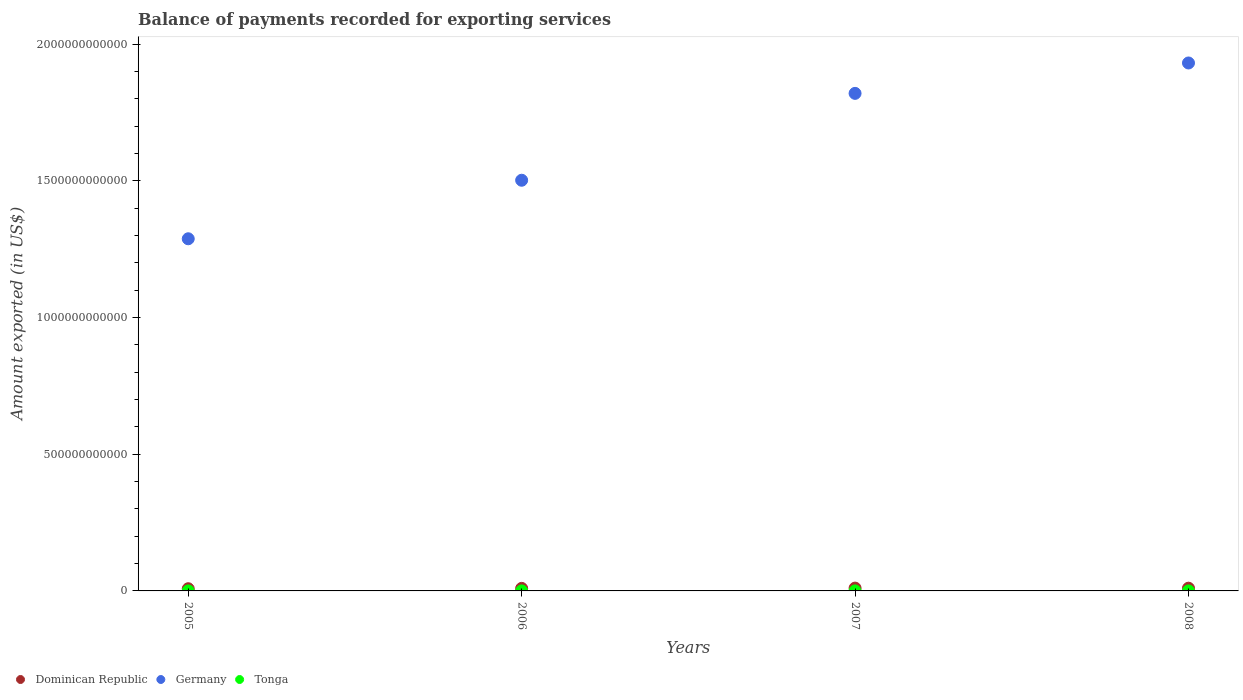How many different coloured dotlines are there?
Your response must be concise. 3. Is the number of dotlines equal to the number of legend labels?
Ensure brevity in your answer.  Yes. What is the amount exported in Tonga in 2007?
Your answer should be compact. 5.55e+07. Across all years, what is the maximum amount exported in Tonga?
Make the answer very short. 6.01e+07. Across all years, what is the minimum amount exported in Germany?
Your response must be concise. 1.29e+12. In which year was the amount exported in Germany maximum?
Make the answer very short. 2008. What is the total amount exported in Dominican Republic in the graph?
Provide a succinct answer. 3.76e+1. What is the difference between the amount exported in Germany in 2005 and that in 2006?
Keep it short and to the point. -2.14e+11. What is the difference between the amount exported in Tonga in 2007 and the amount exported in Dominican Republic in 2008?
Your answer should be compact. -9.94e+09. What is the average amount exported in Germany per year?
Offer a terse response. 1.64e+12. In the year 2007, what is the difference between the amount exported in Germany and amount exported in Dominican Republic?
Your answer should be compact. 1.81e+12. In how many years, is the amount exported in Tonga greater than 900000000000 US$?
Keep it short and to the point. 0. What is the ratio of the amount exported in Germany in 2005 to that in 2007?
Provide a succinct answer. 0.71. Is the amount exported in Tonga in 2005 less than that in 2007?
Ensure brevity in your answer.  No. Is the difference between the amount exported in Germany in 2005 and 2007 greater than the difference between the amount exported in Dominican Republic in 2005 and 2007?
Offer a terse response. No. What is the difference between the highest and the second highest amount exported in Dominican Republic?
Your response must be concise. 3.16e+08. What is the difference between the highest and the lowest amount exported in Germany?
Your answer should be compact. 6.43e+11. In how many years, is the amount exported in Germany greater than the average amount exported in Germany taken over all years?
Your answer should be compact. 2. Is it the case that in every year, the sum of the amount exported in Tonga and amount exported in Dominican Republic  is greater than the amount exported in Germany?
Give a very brief answer. No. Is the amount exported in Dominican Republic strictly greater than the amount exported in Tonga over the years?
Keep it short and to the point. Yes. How many years are there in the graph?
Provide a succinct answer. 4. What is the difference between two consecutive major ticks on the Y-axis?
Keep it short and to the point. 5.00e+11. Are the values on the major ticks of Y-axis written in scientific E-notation?
Make the answer very short. No. Does the graph contain any zero values?
Ensure brevity in your answer.  No. How are the legend labels stacked?
Give a very brief answer. Horizontal. What is the title of the graph?
Provide a succinct answer. Balance of payments recorded for exporting services. What is the label or title of the X-axis?
Give a very brief answer. Years. What is the label or title of the Y-axis?
Your answer should be compact. Amount exported (in US$). What is the Amount exported (in US$) in Dominican Republic in 2005?
Make the answer very short. 8.01e+09. What is the Amount exported (in US$) in Germany in 2005?
Make the answer very short. 1.29e+12. What is the Amount exported (in US$) of Tonga in 2005?
Keep it short and to the point. 5.90e+07. What is the Amount exported (in US$) of Dominican Republic in 2006?
Offer a very short reply. 9.29e+09. What is the Amount exported (in US$) in Germany in 2006?
Your answer should be compact. 1.50e+12. What is the Amount exported (in US$) in Tonga in 2006?
Offer a very short reply. 4.26e+07. What is the Amount exported (in US$) in Dominican Republic in 2007?
Provide a succinct answer. 1.03e+1. What is the Amount exported (in US$) of Germany in 2007?
Your answer should be compact. 1.82e+12. What is the Amount exported (in US$) of Tonga in 2007?
Make the answer very short. 5.55e+07. What is the Amount exported (in US$) in Dominican Republic in 2008?
Your response must be concise. 1.00e+1. What is the Amount exported (in US$) in Germany in 2008?
Give a very brief answer. 1.93e+12. What is the Amount exported (in US$) in Tonga in 2008?
Provide a succinct answer. 6.01e+07. Across all years, what is the maximum Amount exported (in US$) of Dominican Republic?
Keep it short and to the point. 1.03e+1. Across all years, what is the maximum Amount exported (in US$) of Germany?
Provide a short and direct response. 1.93e+12. Across all years, what is the maximum Amount exported (in US$) of Tonga?
Offer a very short reply. 6.01e+07. Across all years, what is the minimum Amount exported (in US$) of Dominican Republic?
Ensure brevity in your answer.  8.01e+09. Across all years, what is the minimum Amount exported (in US$) in Germany?
Offer a terse response. 1.29e+12. Across all years, what is the minimum Amount exported (in US$) of Tonga?
Offer a very short reply. 4.26e+07. What is the total Amount exported (in US$) in Dominican Republic in the graph?
Provide a short and direct response. 3.76e+1. What is the total Amount exported (in US$) of Germany in the graph?
Keep it short and to the point. 6.54e+12. What is the total Amount exported (in US$) in Tonga in the graph?
Offer a very short reply. 2.17e+08. What is the difference between the Amount exported (in US$) of Dominican Republic in 2005 and that in 2006?
Make the answer very short. -1.28e+09. What is the difference between the Amount exported (in US$) in Germany in 2005 and that in 2006?
Your response must be concise. -2.14e+11. What is the difference between the Amount exported (in US$) in Tonga in 2005 and that in 2006?
Your answer should be compact. 1.64e+07. What is the difference between the Amount exported (in US$) of Dominican Republic in 2005 and that in 2007?
Give a very brief answer. -2.30e+09. What is the difference between the Amount exported (in US$) in Germany in 2005 and that in 2007?
Ensure brevity in your answer.  -5.32e+11. What is the difference between the Amount exported (in US$) in Tonga in 2005 and that in 2007?
Offer a very short reply. 3.46e+06. What is the difference between the Amount exported (in US$) in Dominican Republic in 2005 and that in 2008?
Make the answer very short. -1.99e+09. What is the difference between the Amount exported (in US$) of Germany in 2005 and that in 2008?
Keep it short and to the point. -6.43e+11. What is the difference between the Amount exported (in US$) in Tonga in 2005 and that in 2008?
Your answer should be very brief. -1.10e+06. What is the difference between the Amount exported (in US$) in Dominican Republic in 2006 and that in 2007?
Your answer should be very brief. -1.02e+09. What is the difference between the Amount exported (in US$) in Germany in 2006 and that in 2007?
Your answer should be compact. -3.18e+11. What is the difference between the Amount exported (in US$) in Tonga in 2006 and that in 2007?
Your answer should be very brief. -1.30e+07. What is the difference between the Amount exported (in US$) in Dominican Republic in 2006 and that in 2008?
Provide a succinct answer. -7.08e+08. What is the difference between the Amount exported (in US$) of Germany in 2006 and that in 2008?
Keep it short and to the point. -4.29e+11. What is the difference between the Amount exported (in US$) of Tonga in 2006 and that in 2008?
Make the answer very short. -1.75e+07. What is the difference between the Amount exported (in US$) in Dominican Republic in 2007 and that in 2008?
Give a very brief answer. 3.16e+08. What is the difference between the Amount exported (in US$) in Germany in 2007 and that in 2008?
Keep it short and to the point. -1.11e+11. What is the difference between the Amount exported (in US$) in Tonga in 2007 and that in 2008?
Your response must be concise. -4.56e+06. What is the difference between the Amount exported (in US$) in Dominican Republic in 2005 and the Amount exported (in US$) in Germany in 2006?
Offer a terse response. -1.49e+12. What is the difference between the Amount exported (in US$) of Dominican Republic in 2005 and the Amount exported (in US$) of Tonga in 2006?
Provide a short and direct response. 7.97e+09. What is the difference between the Amount exported (in US$) of Germany in 2005 and the Amount exported (in US$) of Tonga in 2006?
Offer a very short reply. 1.29e+12. What is the difference between the Amount exported (in US$) in Dominican Republic in 2005 and the Amount exported (in US$) in Germany in 2007?
Your response must be concise. -1.81e+12. What is the difference between the Amount exported (in US$) of Dominican Republic in 2005 and the Amount exported (in US$) of Tonga in 2007?
Provide a short and direct response. 7.96e+09. What is the difference between the Amount exported (in US$) in Germany in 2005 and the Amount exported (in US$) in Tonga in 2007?
Give a very brief answer. 1.29e+12. What is the difference between the Amount exported (in US$) of Dominican Republic in 2005 and the Amount exported (in US$) of Germany in 2008?
Your answer should be compact. -1.92e+12. What is the difference between the Amount exported (in US$) of Dominican Republic in 2005 and the Amount exported (in US$) of Tonga in 2008?
Provide a succinct answer. 7.95e+09. What is the difference between the Amount exported (in US$) in Germany in 2005 and the Amount exported (in US$) in Tonga in 2008?
Keep it short and to the point. 1.29e+12. What is the difference between the Amount exported (in US$) in Dominican Republic in 2006 and the Amount exported (in US$) in Germany in 2007?
Offer a terse response. -1.81e+12. What is the difference between the Amount exported (in US$) in Dominican Republic in 2006 and the Amount exported (in US$) in Tonga in 2007?
Offer a very short reply. 9.24e+09. What is the difference between the Amount exported (in US$) of Germany in 2006 and the Amount exported (in US$) of Tonga in 2007?
Offer a very short reply. 1.50e+12. What is the difference between the Amount exported (in US$) of Dominican Republic in 2006 and the Amount exported (in US$) of Germany in 2008?
Provide a short and direct response. -1.92e+12. What is the difference between the Amount exported (in US$) in Dominican Republic in 2006 and the Amount exported (in US$) in Tonga in 2008?
Ensure brevity in your answer.  9.23e+09. What is the difference between the Amount exported (in US$) in Germany in 2006 and the Amount exported (in US$) in Tonga in 2008?
Your response must be concise. 1.50e+12. What is the difference between the Amount exported (in US$) of Dominican Republic in 2007 and the Amount exported (in US$) of Germany in 2008?
Your answer should be very brief. -1.92e+12. What is the difference between the Amount exported (in US$) of Dominican Republic in 2007 and the Amount exported (in US$) of Tonga in 2008?
Provide a succinct answer. 1.03e+1. What is the difference between the Amount exported (in US$) in Germany in 2007 and the Amount exported (in US$) in Tonga in 2008?
Provide a succinct answer. 1.82e+12. What is the average Amount exported (in US$) in Dominican Republic per year?
Provide a short and direct response. 9.40e+09. What is the average Amount exported (in US$) in Germany per year?
Your response must be concise. 1.64e+12. What is the average Amount exported (in US$) in Tonga per year?
Your answer should be very brief. 5.43e+07. In the year 2005, what is the difference between the Amount exported (in US$) of Dominican Republic and Amount exported (in US$) of Germany?
Your answer should be very brief. -1.28e+12. In the year 2005, what is the difference between the Amount exported (in US$) of Dominican Republic and Amount exported (in US$) of Tonga?
Your answer should be very brief. 7.95e+09. In the year 2005, what is the difference between the Amount exported (in US$) of Germany and Amount exported (in US$) of Tonga?
Give a very brief answer. 1.29e+12. In the year 2006, what is the difference between the Amount exported (in US$) in Dominican Republic and Amount exported (in US$) in Germany?
Provide a succinct answer. -1.49e+12. In the year 2006, what is the difference between the Amount exported (in US$) in Dominican Republic and Amount exported (in US$) in Tonga?
Provide a succinct answer. 9.25e+09. In the year 2006, what is the difference between the Amount exported (in US$) of Germany and Amount exported (in US$) of Tonga?
Your answer should be very brief. 1.50e+12. In the year 2007, what is the difference between the Amount exported (in US$) in Dominican Republic and Amount exported (in US$) in Germany?
Offer a terse response. -1.81e+12. In the year 2007, what is the difference between the Amount exported (in US$) in Dominican Republic and Amount exported (in US$) in Tonga?
Your answer should be very brief. 1.03e+1. In the year 2007, what is the difference between the Amount exported (in US$) in Germany and Amount exported (in US$) in Tonga?
Give a very brief answer. 1.82e+12. In the year 2008, what is the difference between the Amount exported (in US$) of Dominican Republic and Amount exported (in US$) of Germany?
Give a very brief answer. -1.92e+12. In the year 2008, what is the difference between the Amount exported (in US$) of Dominican Republic and Amount exported (in US$) of Tonga?
Your answer should be very brief. 9.94e+09. In the year 2008, what is the difference between the Amount exported (in US$) in Germany and Amount exported (in US$) in Tonga?
Your answer should be compact. 1.93e+12. What is the ratio of the Amount exported (in US$) of Dominican Republic in 2005 to that in 2006?
Your answer should be compact. 0.86. What is the ratio of the Amount exported (in US$) in Germany in 2005 to that in 2006?
Your response must be concise. 0.86. What is the ratio of the Amount exported (in US$) of Tonga in 2005 to that in 2006?
Your response must be concise. 1.39. What is the ratio of the Amount exported (in US$) of Dominican Republic in 2005 to that in 2007?
Give a very brief answer. 0.78. What is the ratio of the Amount exported (in US$) in Germany in 2005 to that in 2007?
Your answer should be very brief. 0.71. What is the ratio of the Amount exported (in US$) of Tonga in 2005 to that in 2007?
Your response must be concise. 1.06. What is the ratio of the Amount exported (in US$) of Dominican Republic in 2005 to that in 2008?
Your response must be concise. 0.8. What is the ratio of the Amount exported (in US$) of Germany in 2005 to that in 2008?
Provide a succinct answer. 0.67. What is the ratio of the Amount exported (in US$) of Tonga in 2005 to that in 2008?
Provide a succinct answer. 0.98. What is the ratio of the Amount exported (in US$) of Dominican Republic in 2006 to that in 2007?
Keep it short and to the point. 0.9. What is the ratio of the Amount exported (in US$) of Germany in 2006 to that in 2007?
Provide a short and direct response. 0.83. What is the ratio of the Amount exported (in US$) of Tonga in 2006 to that in 2007?
Offer a very short reply. 0.77. What is the ratio of the Amount exported (in US$) in Dominican Republic in 2006 to that in 2008?
Make the answer very short. 0.93. What is the ratio of the Amount exported (in US$) in Germany in 2006 to that in 2008?
Your response must be concise. 0.78. What is the ratio of the Amount exported (in US$) of Tonga in 2006 to that in 2008?
Keep it short and to the point. 0.71. What is the ratio of the Amount exported (in US$) in Dominican Republic in 2007 to that in 2008?
Offer a terse response. 1.03. What is the ratio of the Amount exported (in US$) of Germany in 2007 to that in 2008?
Keep it short and to the point. 0.94. What is the ratio of the Amount exported (in US$) of Tonga in 2007 to that in 2008?
Ensure brevity in your answer.  0.92. What is the difference between the highest and the second highest Amount exported (in US$) in Dominican Republic?
Your answer should be very brief. 3.16e+08. What is the difference between the highest and the second highest Amount exported (in US$) in Germany?
Ensure brevity in your answer.  1.11e+11. What is the difference between the highest and the second highest Amount exported (in US$) of Tonga?
Keep it short and to the point. 1.10e+06. What is the difference between the highest and the lowest Amount exported (in US$) of Dominican Republic?
Make the answer very short. 2.30e+09. What is the difference between the highest and the lowest Amount exported (in US$) of Germany?
Provide a short and direct response. 6.43e+11. What is the difference between the highest and the lowest Amount exported (in US$) in Tonga?
Give a very brief answer. 1.75e+07. 